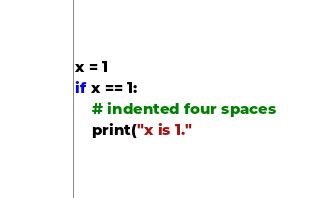<code> <loc_0><loc_0><loc_500><loc_500><_Python_>x = 1
if x == 1:
    # indented four spaces
    print("x is 1."
</code> 